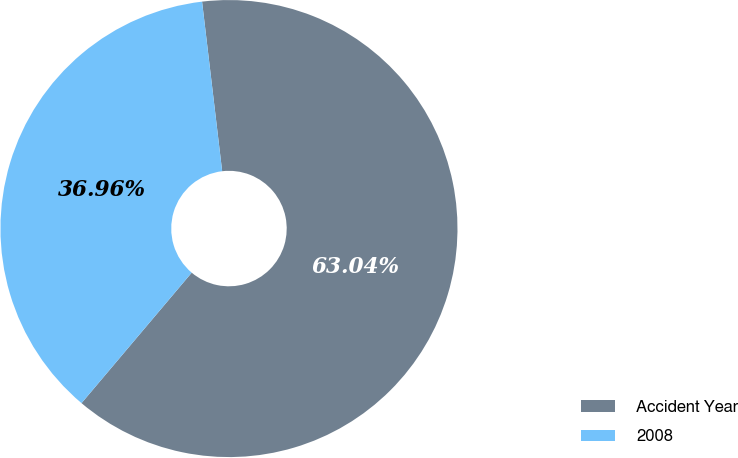Convert chart to OTSL. <chart><loc_0><loc_0><loc_500><loc_500><pie_chart><fcel>Accident Year<fcel>2008<nl><fcel>63.04%<fcel>36.96%<nl></chart> 